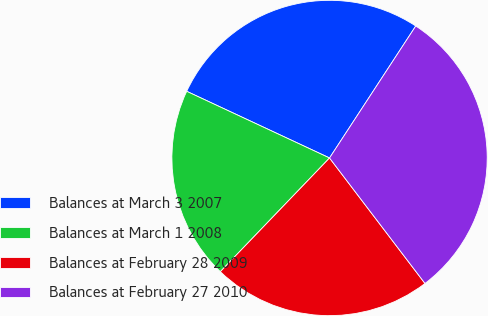<chart> <loc_0><loc_0><loc_500><loc_500><pie_chart><fcel>Balances at March 3 2007<fcel>Balances at March 1 2008<fcel>Balances at February 28 2009<fcel>Balances at February 27 2010<nl><fcel>27.26%<fcel>19.77%<fcel>22.53%<fcel>30.44%<nl></chart> 